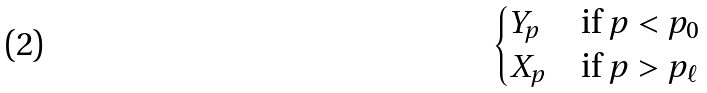<formula> <loc_0><loc_0><loc_500><loc_500>\begin{cases} Y _ { p } & \text {if $p < p_{0}$} \\ X _ { p } & \text {if $p > p_{\ell}$} \end{cases}</formula> 